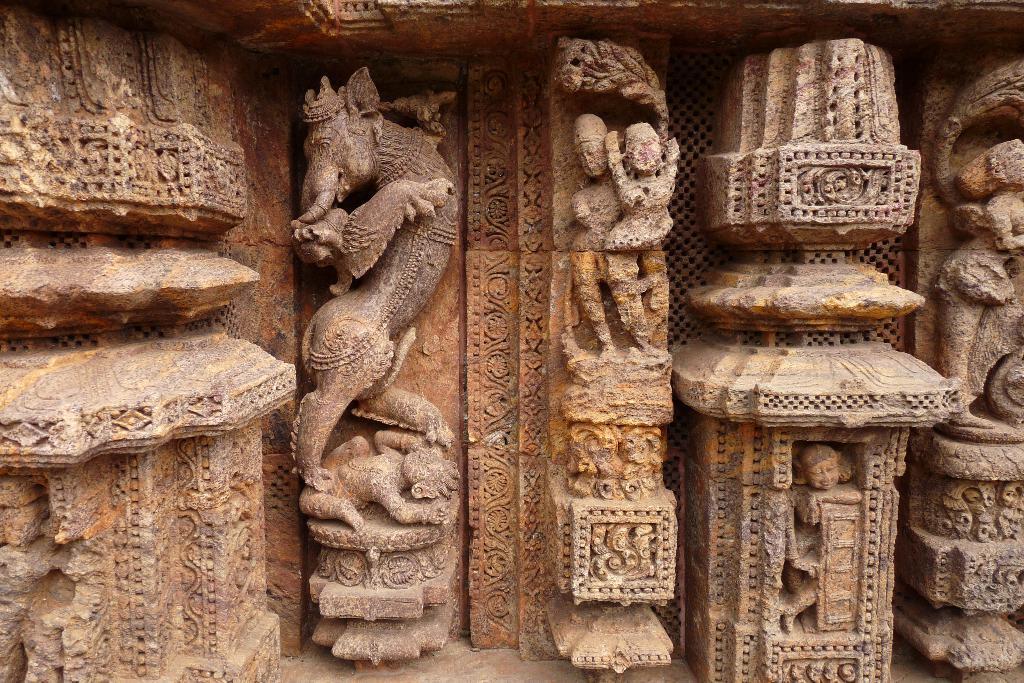Can you describe this image briefly? In the picture we can see a historical temple wall with some sculptures to it and they are brown in color. 